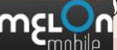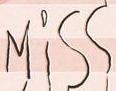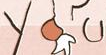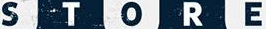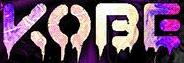What text appears in these images from left to right, separated by a semicolon? mɛLon; Miss; you; STORE; KOBE 